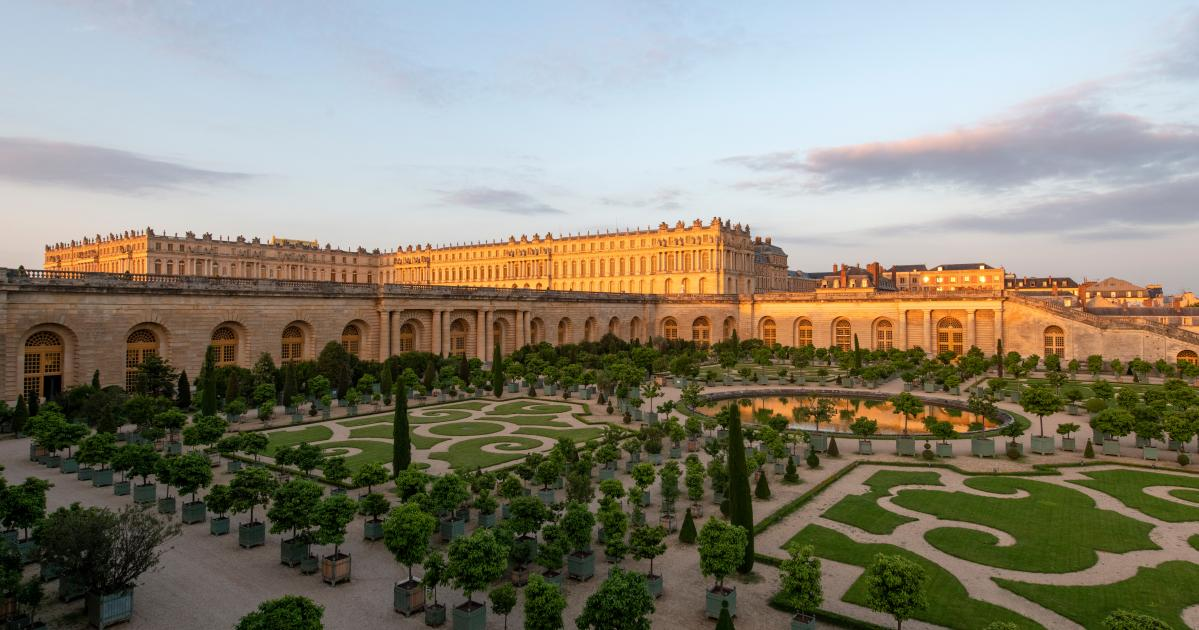Imagine you are a visitor in this palace. Describe your experience. As you step through the grand entrance of the Palace of Versailles, you're immediately struck by the opulence that surrounds you. Marble floors glisten under the soft, warm light filtering through the numerous windows. Ornate chandeliers hang from high ceilings adorned with intricate frescoes. Walking through the lavish halls, you feel a sense of grandeur and history, imagining the lives of the royals who once inhabited these walls. Stepping out into the gardens, you're greeted by the sight of perfectly manicured lawns, vibrant flower beds, and the soothing sound of water trickling from the grand fountain, all coming together to create a peaceful and awe-inspiring ambiance. 